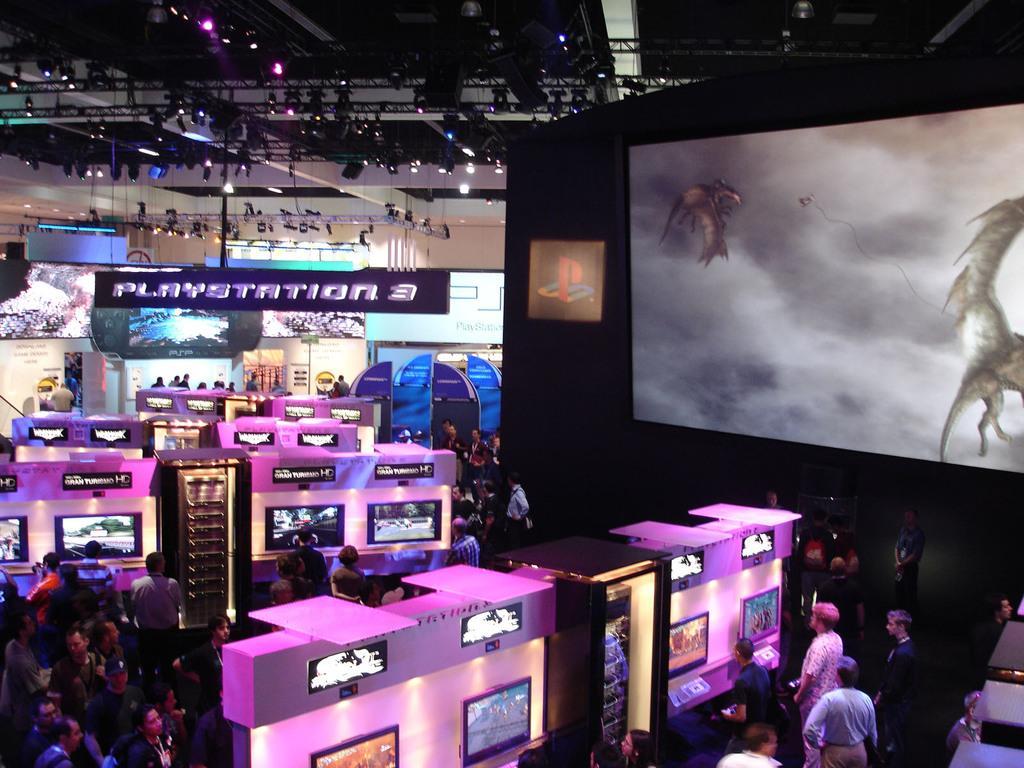Please provide a concise description of this image. In this image I can see few screens and white and pink color boards. I can see group of people and large screen. Back I can see colorful borders and lights. 